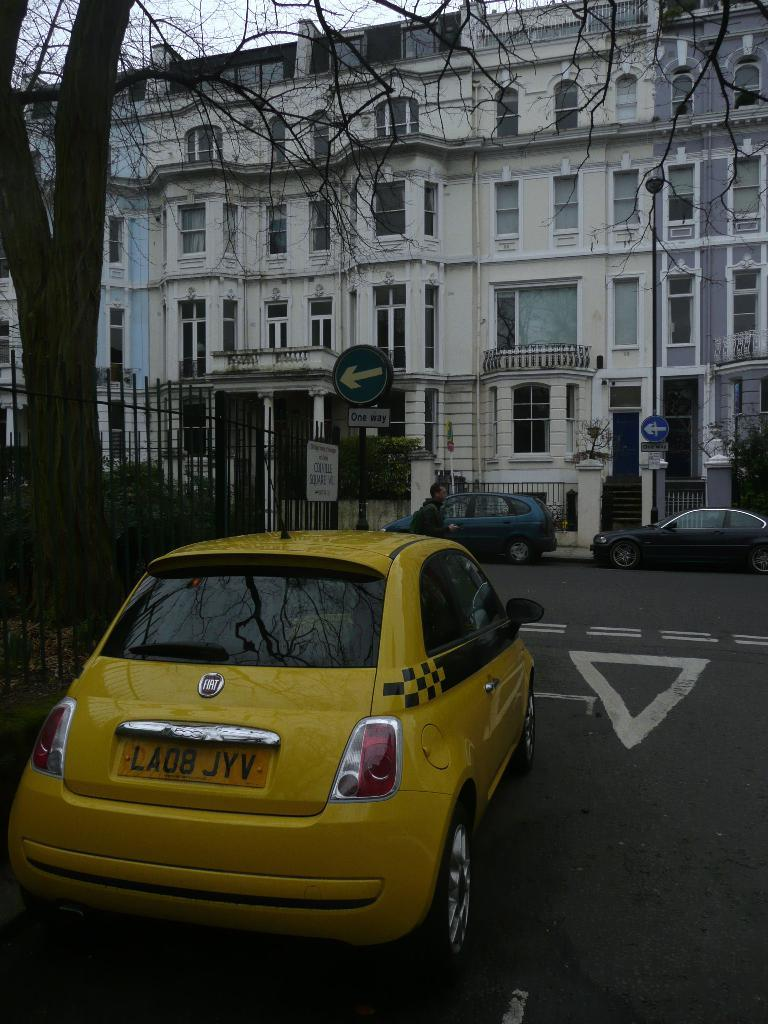<image>
Give a short and clear explanation of the subsequent image. A yellow Fiat taxi is travelling toward a one way street. 